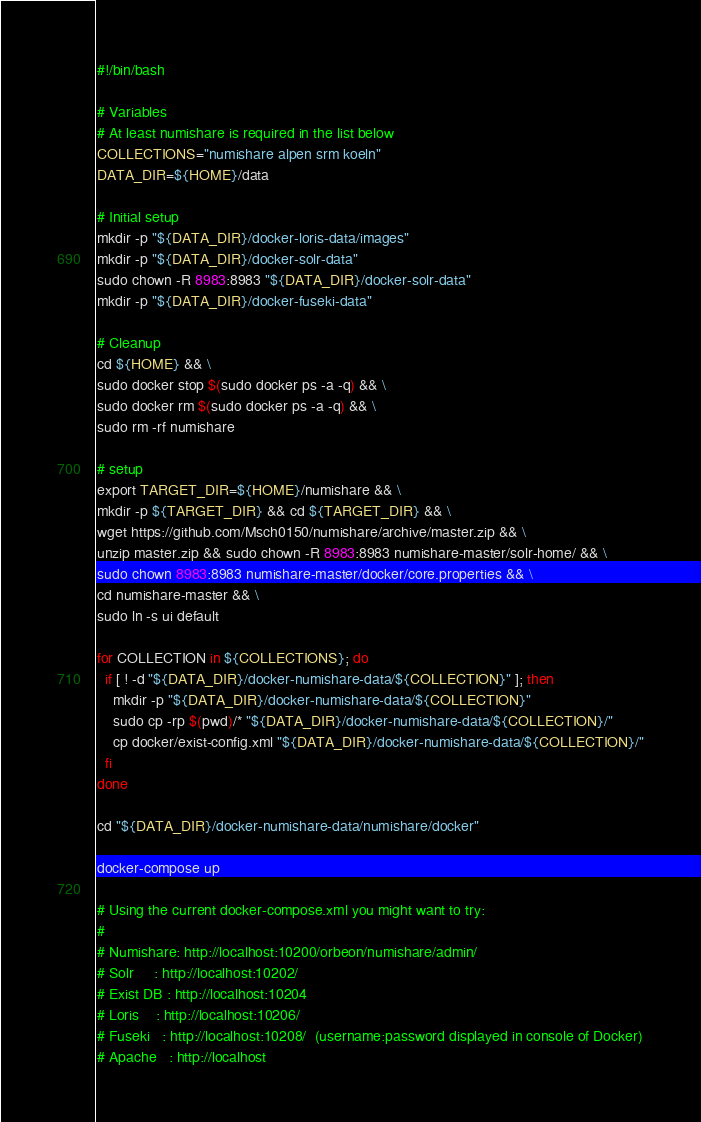Convert code to text. <code><loc_0><loc_0><loc_500><loc_500><_Bash_>#!/bin/bash

# Variables
# At least numishare is required in the list below
COLLECTIONS="numishare alpen srm koeln"
DATA_DIR=${HOME}/data

# Initial setup
mkdir -p "${DATA_DIR}/docker-loris-data/images"
mkdir -p "${DATA_DIR}/docker-solr-data"
sudo chown -R 8983:8983 "${DATA_DIR}/docker-solr-data"
mkdir -p "${DATA_DIR}/docker-fuseki-data"

# Cleanup
cd ${HOME} && \
sudo docker stop $(sudo docker ps -a -q) && \
sudo docker rm $(sudo docker ps -a -q) && \
sudo rm -rf numishare

# setup
export TARGET_DIR=${HOME}/numishare && \
mkdir -p ${TARGET_DIR} && cd ${TARGET_DIR} && \
wget https://github.com/Msch0150/numishare/archive/master.zip && \
unzip master.zip && sudo chown -R 8983:8983 numishare-master/solr-home/ && \
sudo chown 8983:8983 numishare-master/docker/core.properties && \
cd numishare-master && \
sudo ln -s ui default

for COLLECTION in ${COLLECTIONS}; do
  if [ ! -d "${DATA_DIR}/docker-numishare-data/${COLLECTION}" ]; then
    mkdir -p "${DATA_DIR}/docker-numishare-data/${COLLECTION}"
    sudo cp -rp $(pwd)/* "${DATA_DIR}/docker-numishare-data/${COLLECTION}/"
    cp docker/exist-config.xml "${DATA_DIR}/docker-numishare-data/${COLLECTION}/"
  fi
done

cd "${DATA_DIR}/docker-numishare-data/numishare/docker"

docker-compose up

# Using the current docker-compose.xml you might want to try:
#
# Numishare: http://localhost:10200/orbeon/numishare/admin/
# Solr     : http://localhost:10202/
# Exist DB : http://localhost:10204
# Loris    : http://localhost:10206/
# Fuseki   : http://localhost:10208/  (username:password displayed in console of Docker)
# Apache   : http://localhost

</code> 